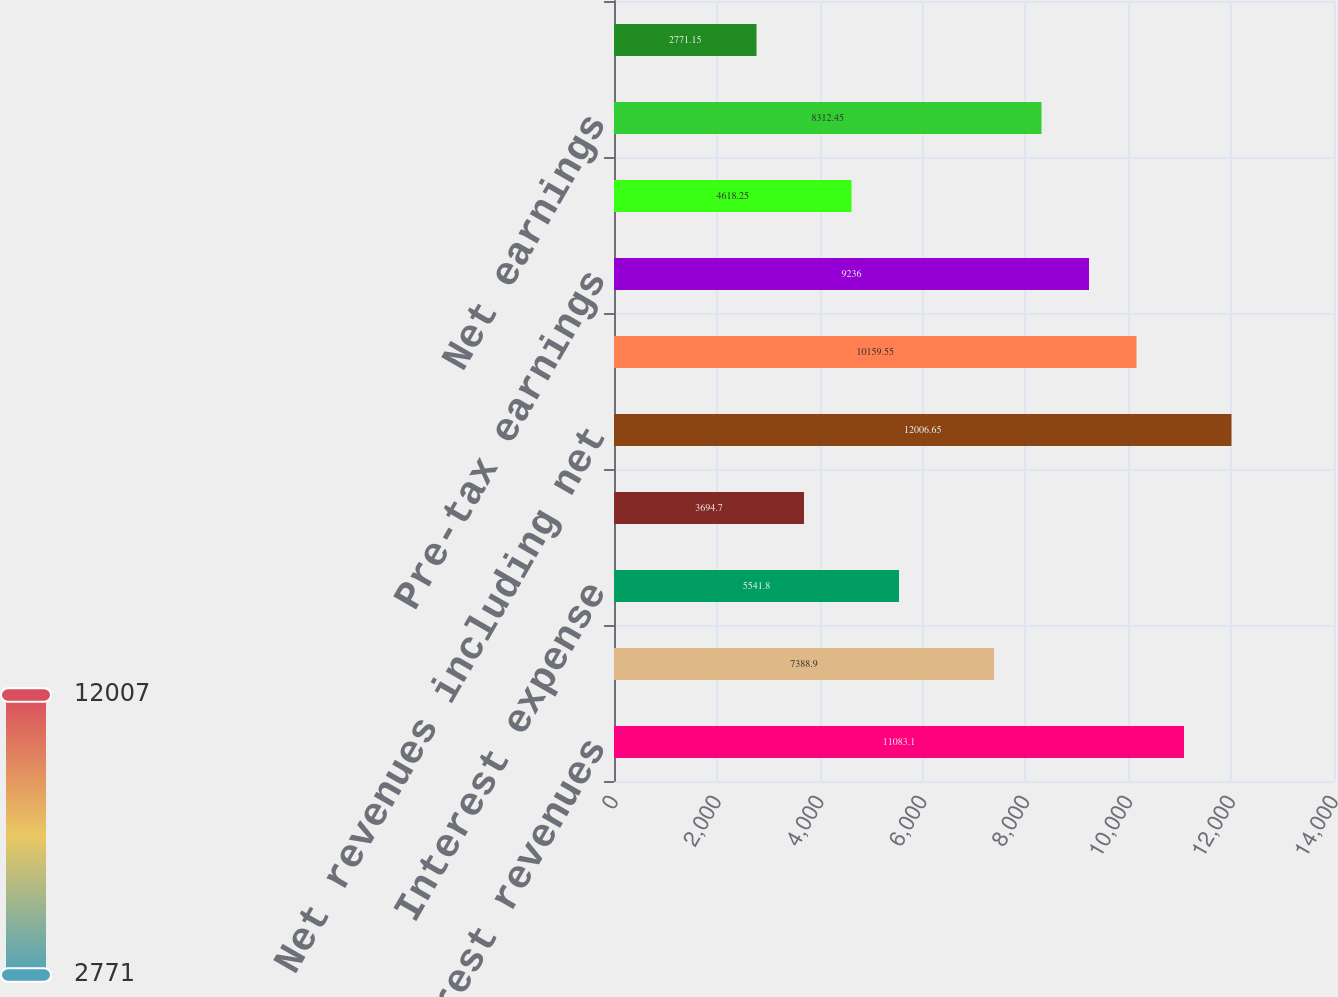<chart> <loc_0><loc_0><loc_500><loc_500><bar_chart><fcel>Total non-interest revenues<fcel>Interest income<fcel>Interest expense<fcel>Net interest income<fcel>Net revenues including net<fcel>Operating expenses 1<fcel>Pre-tax earnings<fcel>Provision for taxes<fcel>Net earnings<fcel>Preferred stock dividends<nl><fcel>11083.1<fcel>7388.9<fcel>5541.8<fcel>3694.7<fcel>12006.6<fcel>10159.5<fcel>9236<fcel>4618.25<fcel>8312.45<fcel>2771.15<nl></chart> 